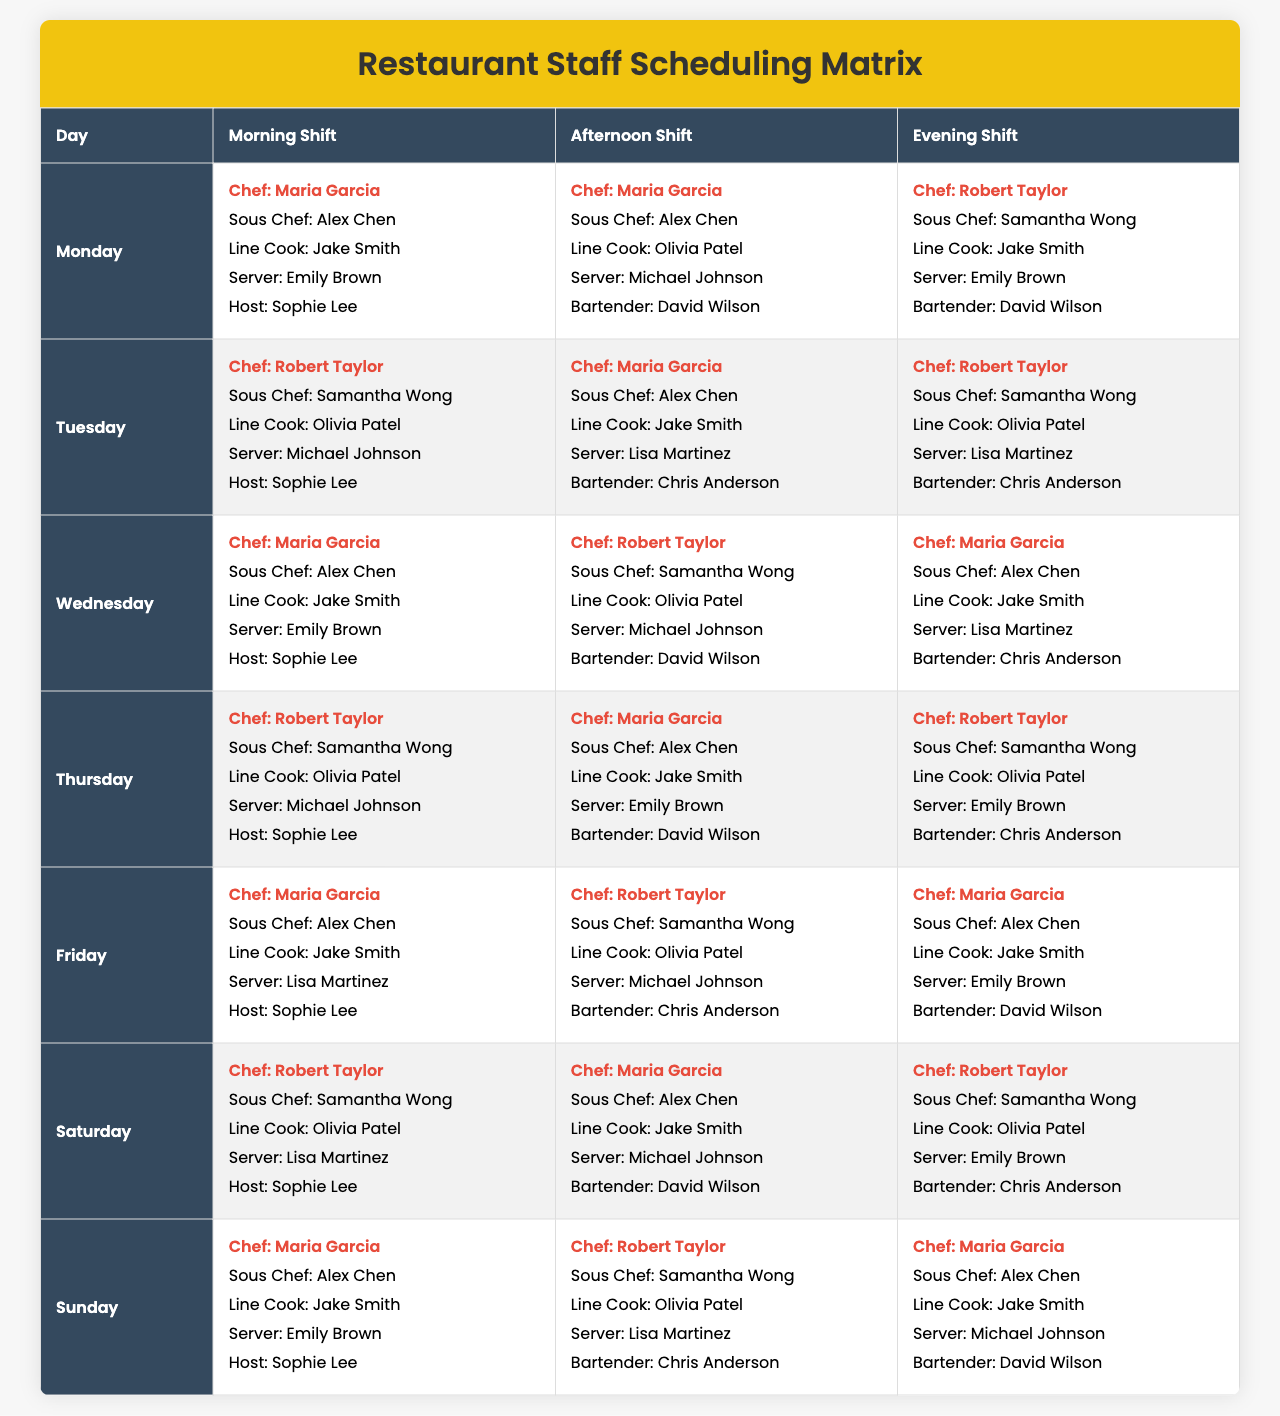What chef is scheduled for the morning shift on Wednesday? The table shows that on Wednesday, the morning shift is covered by Maria Garcia as per the data provided for that day.
Answer: Maria Garcia How many unique servers are working throughout the week? By looking through the schedule for each day, the unique names listed for the server role are Emily Brown, Michael Johnson, Lisa Martinez, and Sophie Lee. There are a total of 4 unique server names.
Answer: 4 Is Robert Taylor scheduled to work in the evening shift on Friday? On Friday, the evening shift has Robert Taylor listed as the chef. Thus, yes, he is scheduled to work that evening.
Answer: Yes Which day has the maximum number of cooks scheduled? To determine this, I counted the unique line cooks for each day. Every day has a line cook, and the maximum across all days remains constant at 1 per day, so the answer is that each day has the same amount (1).
Answer: All days have 1 cook Which chef has the most evening shifts? By reviewing the evening shift across each day, both Maria Garcia and Robert Taylor appear twice in that role throughout the week. Hence, they share the most evening shifts.
Answer: Maria Garcia and Robert Taylor On which day is Emily Brown NOT scheduled to work? Emily Brown works on Monday, Wednesday, Thursday, and Saturday. Therefore, the days she is not scheduled are Tuesday, Friday, and Sunday.
Answer: Tuesday, Friday, Sunday What is the total count of chefs scheduled for the weekend (Saturday and Sunday)? Checking the schedule for Saturday shows Maria Garcia and Robert Taylor, while Sunday has Maria Garcia and Robert Taylor again. This totals to 4 instances of chefs scheduled on weekend days.
Answer: 4 Are there any days where the same team (chef, sous chef, line cook, server, bartender) is repeated? Tuesday has the same team of Robert Taylor, Samantha Wong, Olivia Patel, Lisa Martinez, and Chris Anderson who are repeated in shift arrangements on the same day.
Answer: Yes How many different roles does David Wilson fill across the week? David Wilson is scheduled as a bartender on both Tuesday and Saturday, but does not fill any other role. Thus, he has one role through the week.
Answer: 1 Which server worked the evening shift on Saturday? In the evening shift for Saturday, Lisa Martinez is listed as the server.
Answer: Lisa Martinez 